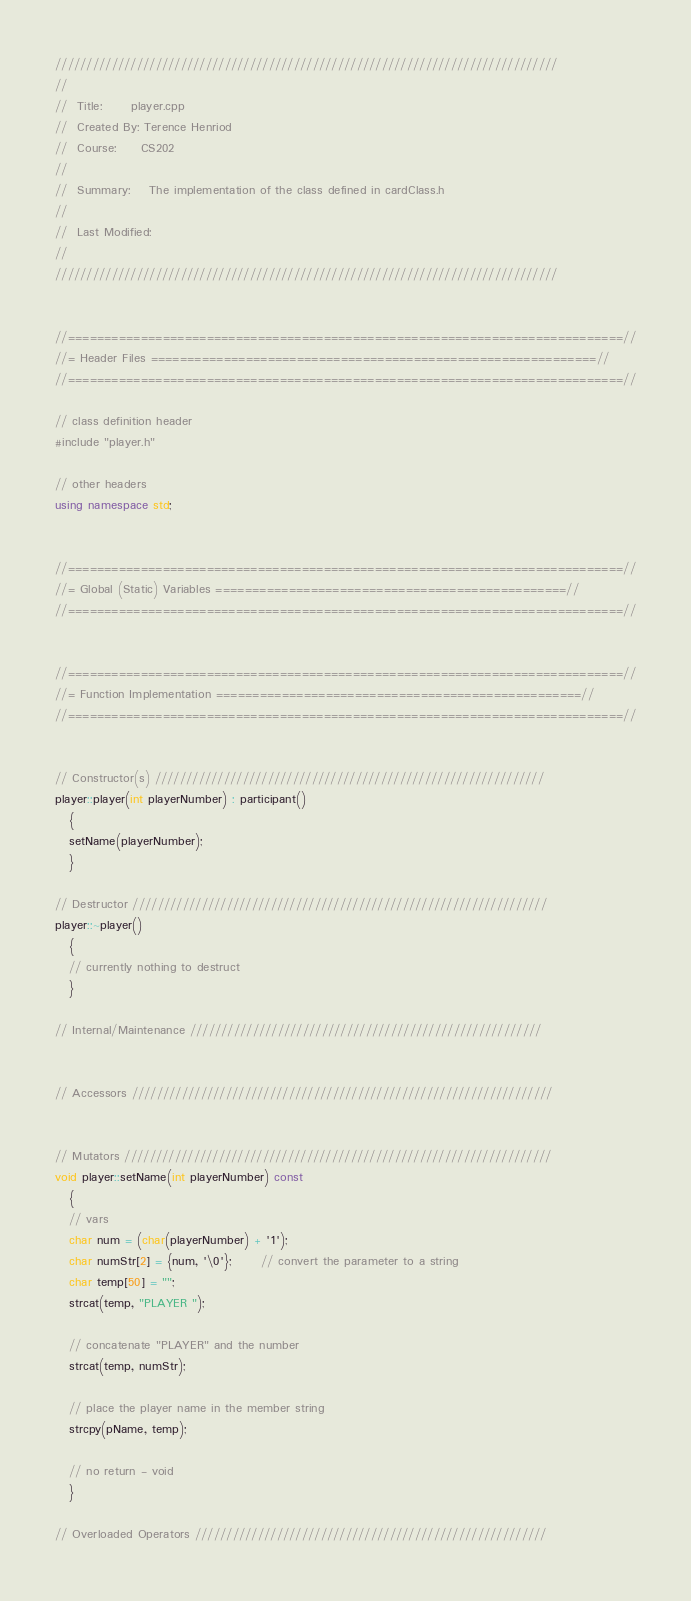Convert code to text. <code><loc_0><loc_0><loc_500><loc_500><_C++_>////////////////////////////////////////////////////////////////////////////////
// 
//  Title:      player.cpp
//  Created By: Terence Henriod
//  Course:     CS202
//
//  Summary:    The implementation of the class defined in cardClass.h
// 
//  Last Modified: 
//
////////////////////////////////////////////////////////////////////////////////


//============================================================================//
//= Header Files =============================================================//
//============================================================================//

// class definition header
#include "player.h"

// other headers
using namespace std;


//============================================================================//
//= Global (Static) Variables ================================================//
//============================================================================//


//============================================================================//
//= Function Implementation ==================================================//
//============================================================================//


// Constructor(s) //////////////////////////////////////////////////////////////
player::player(int playerNumber) : participant()
   {
   setName(playerNumber);
   }

// Destructor //////////////////////////////////////////////////////////////////
player::~player()
   {
   // currently nothing to destruct
   }

// Internal/Maintenance ////////////////////////////////////////////////////////


// Accessors ///////////////////////////////////////////////////////////////////


// Mutators ////////////////////////////////////////////////////////////////////
void player::setName(int playerNumber) const
   {
   // vars
   char num = (char(playerNumber) + '1');
   char numStr[2] = {num, '\0'};      // convert the parameter to a string
   char temp[50] = "";
   strcat(temp, "PLAYER ");

   // concatenate "PLAYER" and the number
   strcat(temp, numStr);

   // place the player name in the member string
   strcpy(pName, temp);    

   // no return - void
   }

// Overloaded Operators ////////////////////////////////////////////////////////

</code> 